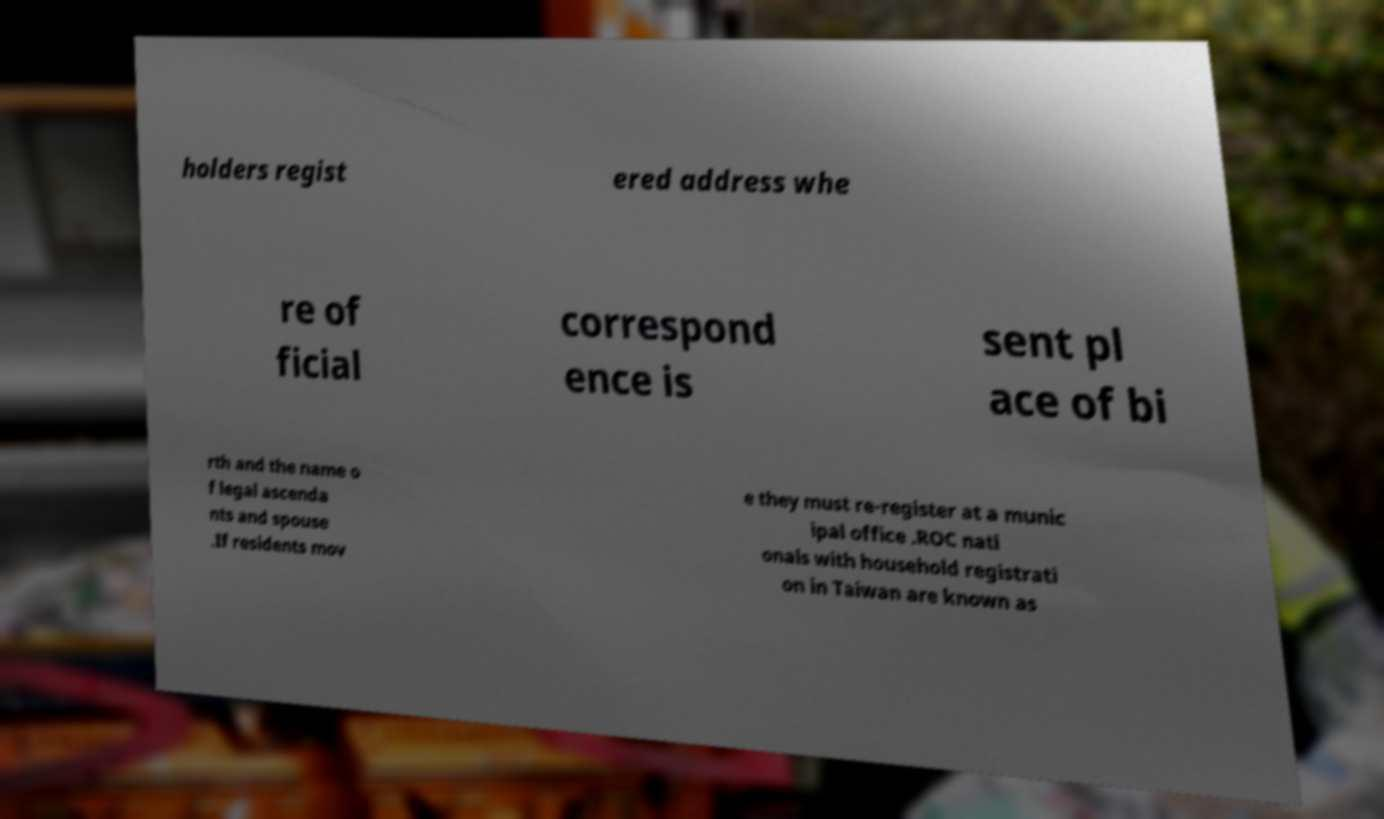What messages or text are displayed in this image? I need them in a readable, typed format. holders regist ered address whe re of ficial correspond ence is sent pl ace of bi rth and the name o f legal ascenda nts and spouse .If residents mov e they must re-register at a munic ipal office .ROC nati onals with household registrati on in Taiwan are known as 